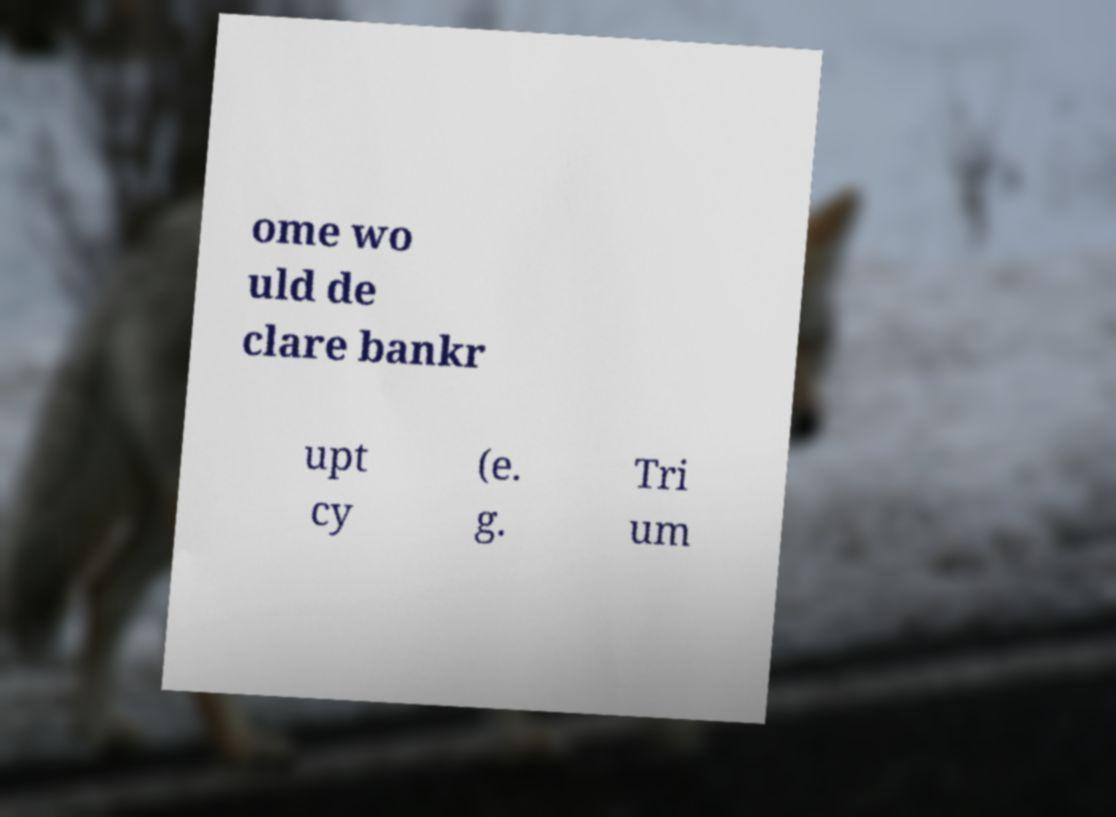Can you accurately transcribe the text from the provided image for me? ome wo uld de clare bankr upt cy (e. g. Tri um 